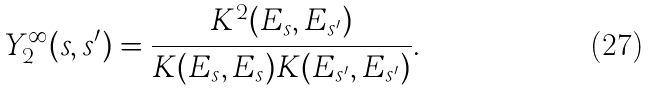<formula> <loc_0><loc_0><loc_500><loc_500>Y _ { 2 } ^ { \infty } ( s , s ^ { \prime } ) = \frac { K ^ { 2 } ( E _ { s } , E _ { s ^ { \prime } } ) } { K ( E _ { s } , E _ { s } ) K ( E _ { s ^ { \prime } } , E _ { s ^ { \prime } } ) } .</formula> 